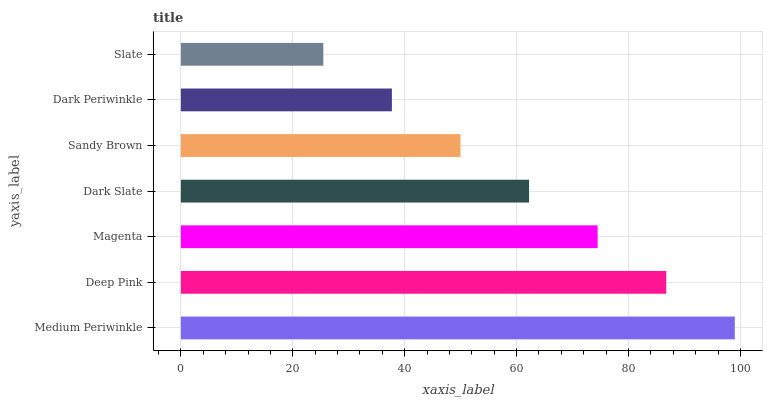Is Slate the minimum?
Answer yes or no. Yes. Is Medium Periwinkle the maximum?
Answer yes or no. Yes. Is Deep Pink the minimum?
Answer yes or no. No. Is Deep Pink the maximum?
Answer yes or no. No. Is Medium Periwinkle greater than Deep Pink?
Answer yes or no. Yes. Is Deep Pink less than Medium Periwinkle?
Answer yes or no. Yes. Is Deep Pink greater than Medium Periwinkle?
Answer yes or no. No. Is Medium Periwinkle less than Deep Pink?
Answer yes or no. No. Is Dark Slate the high median?
Answer yes or no. Yes. Is Dark Slate the low median?
Answer yes or no. Yes. Is Medium Periwinkle the high median?
Answer yes or no. No. Is Medium Periwinkle the low median?
Answer yes or no. No. 